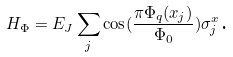Convert formula to latex. <formula><loc_0><loc_0><loc_500><loc_500>H _ { \Phi } = E _ { J } \sum _ { j } \cos ( \frac { \pi \Phi _ { q } ( x _ { j } ) } { \Phi _ { 0 } } ) \sigma ^ { x } _ { j } \text {.}</formula> 